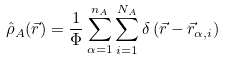<formula> <loc_0><loc_0><loc_500><loc_500>\hat { \rho } _ { A } ( \vec { r } ) = \frac { 1 } { \Phi } \sum _ { \alpha = 1 } ^ { n _ { A } } \sum _ { i = 1 } ^ { N _ { A } } \delta \left ( \vec { r } - \vec { r } _ { \alpha , i } \right )</formula> 